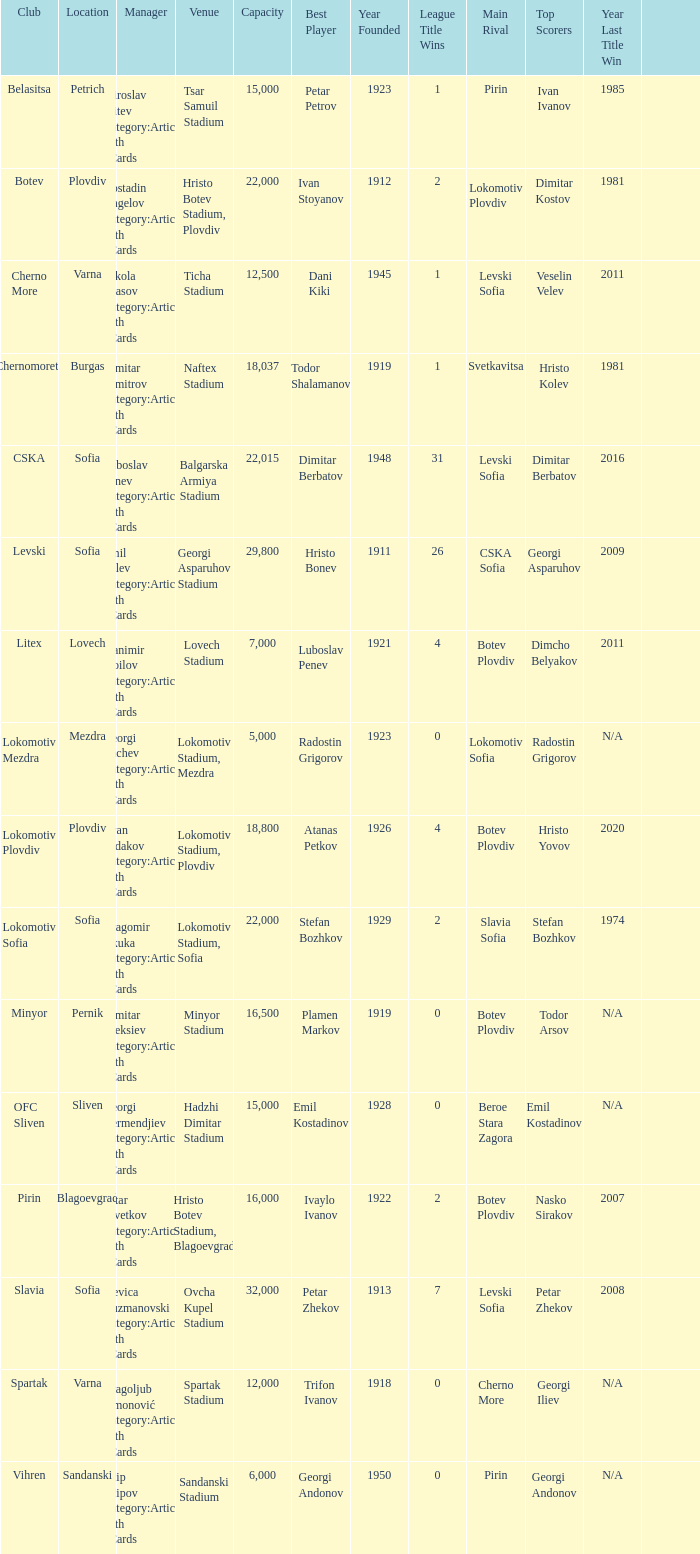Can you give me this table as a dict? {'header': ['Club', 'Location', 'Manager', 'Venue', 'Capacity', 'Best Player', 'Year Founded', 'League Title Wins', 'Main Rival', 'Top Scorers', 'Year Last Title Win', ''], 'rows': [['Belasitsa', 'Petrich', 'Miroslav Mitev Category:Articles with hCards', 'Tsar Samuil Stadium', '15,000', 'Petar Petrov', '1923', '1', 'Pirin', 'Ivan Ivanov', '1985', ''], ['Botev', 'Plovdiv', 'Kostadin Angelov Category:Articles with hCards', 'Hristo Botev Stadium, Plovdiv', '22,000', 'Ivan Stoyanov', '1912', '2', 'Lokomotiv Plovdiv', 'Dimitar Kostov', '1981', ''], ['Cherno More', 'Varna', 'Nikola Spasov Category:Articles with hCards', 'Ticha Stadium', '12,500', 'Dani Kiki', '1945', '1', 'Levski Sofia', 'Veselin Velev', '2011', ''], ['Chernomorets', 'Burgas', 'Dimitar Dimitrov Category:Articles with hCards', 'Naftex Stadium', '18,037', 'Todor Shalamanov', '1919', '1', 'Svetkavitsa', 'Hristo Kolev', '1981', ''], ['CSKA', 'Sofia', 'Luboslav Penev Category:Articles with hCards', 'Balgarska Armiya Stadium', '22,015', 'Dimitar Berbatov', '1948', '31', 'Levski Sofia', 'Dimitar Berbatov', '2016', ''], ['Levski', 'Sofia', 'Emil Velev Category:Articles with hCards', 'Georgi Asparuhov Stadium', '29,800', 'Hristo Bonev', '1911', '26', 'CSKA Sofia', 'Georgi Asparuhov', '2009', ''], ['Litex', 'Lovech', 'Stanimir Stoilov Category:Articles with hCards', 'Lovech Stadium', '7,000', 'Luboslav Penev', '1921', '4', 'Botev Plovdiv', 'Dimcho Belyakov', '2011', ''], ['Lokomotiv Mezdra', 'Mezdra', 'Georgi Bachev Category:Articles with hCards', 'Lokomotiv Stadium, Mezdra', '5,000', 'Radostin Grigorov', '1923', '0', 'Lokomotiv Sofia', 'Radostin Grigorov', 'N/A', ''], ['Lokomotiv Plovdiv', 'Plovdiv', 'Ayan Sadakov Category:Articles with hCards', 'Lokomotiv Stadium, Plovdiv', '18,800', 'Atanas Petkov', '1926', '4', 'Botev Plovdiv', 'Hristo Yovov', '2020', ''], ['Lokomotiv Sofia', 'Sofia', 'Dragomir Okuka Category:Articles with hCards', 'Lokomotiv Stadium, Sofia', '22,000', 'Stefan Bozhkov', '1929', '2', 'Slavia Sofia', 'Stefan Bozhkov', '1974', ''], ['Minyor', 'Pernik', 'Dimitar Aleksiev Category:Articles with hCards', 'Minyor Stadium', '16,500', 'Plamen Markov', '1919', '0', 'Botev Plovdiv', 'Todor Arsov', 'N/A', ''], ['OFC Sliven', 'Sliven', 'Georgi Dermendjiev Category:Articles with hCards', 'Hadzhi Dimitar Stadium', '15,000', 'Emil Kostadinov', '1928', '0', 'Beroe Stara Zagora', 'Emil Kostadinov', 'N/A', ''], ['Pirin', 'Blagoevgrad', 'Petar Tsvetkov Category:Articles with hCards', 'Hristo Botev Stadium, Blagoevgrad', '16,000', 'Ivaylo Ivanov', '1922', '2', 'Botev Plovdiv', 'Nasko Sirakov', '2007', ''], ['Slavia', 'Sofia', 'Stevica Kuzmanovski Category:Articles with hCards', 'Ovcha Kupel Stadium', '32,000', 'Petar Zhekov', '1913', '7', 'Levski Sofia', 'Petar Zhekov', '2008', ''], ['Spartak', 'Varna', 'Dragoljub Simonović Category:Articles with hCards', 'Spartak Stadium', '12,000', 'Trifon Ivanov', '1918', '0', 'Cherno More', 'Georgi Iliev', 'N/A', ''], ['Vihren', 'Sandanski', 'Filip Filipov Category:Articles with hCards', 'Sandanski Stadium', '6,000', 'Georgi Andonov', '1950', '0', 'Pirin', 'Georgi Andonov', 'N/A', '']]} What is the highest capacity for the venue of the club, vihren? 6000.0. 